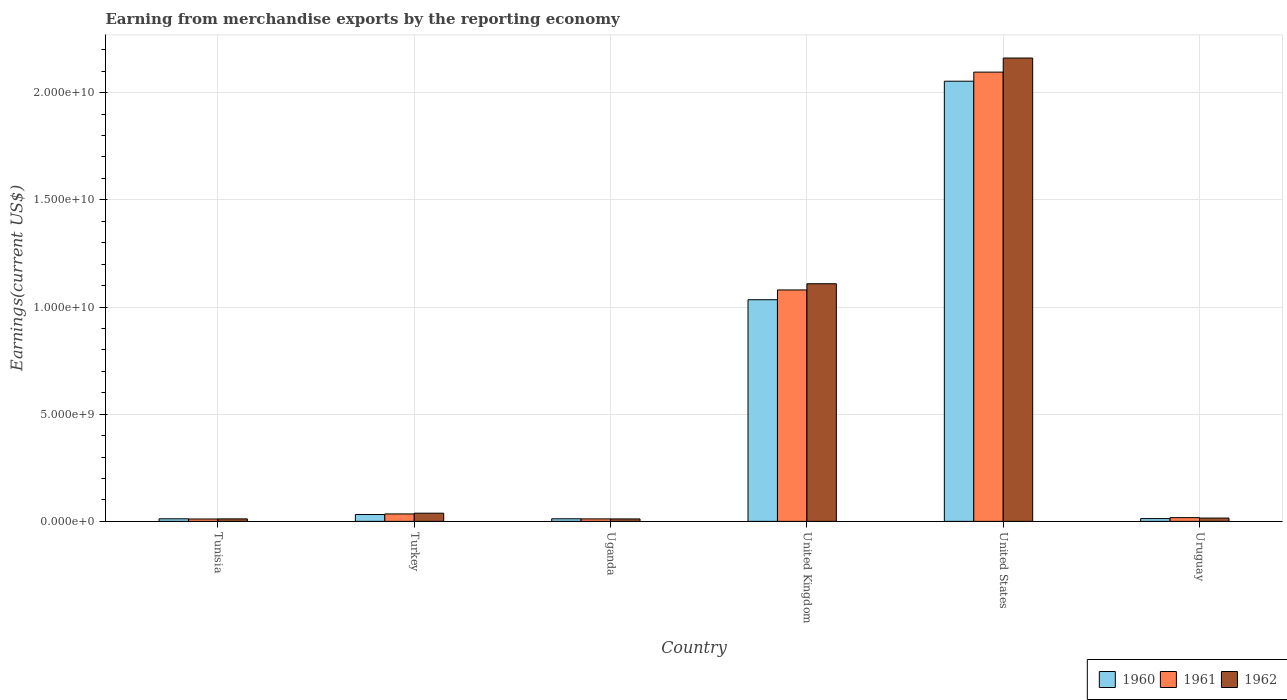How many groups of bars are there?
Keep it short and to the point. 6. Are the number of bars per tick equal to the number of legend labels?
Provide a succinct answer. Yes. Are the number of bars on each tick of the X-axis equal?
Offer a very short reply. Yes. How many bars are there on the 5th tick from the left?
Give a very brief answer. 3. How many bars are there on the 2nd tick from the right?
Offer a very short reply. 3. What is the label of the 6th group of bars from the left?
Your answer should be very brief. Uruguay. In how many cases, is the number of bars for a given country not equal to the number of legend labels?
Ensure brevity in your answer.  0. What is the amount earned from merchandise exports in 1961 in United Kingdom?
Your answer should be very brief. 1.08e+1. Across all countries, what is the maximum amount earned from merchandise exports in 1960?
Your answer should be compact. 2.05e+1. Across all countries, what is the minimum amount earned from merchandise exports in 1961?
Offer a terse response. 1.10e+08. In which country was the amount earned from merchandise exports in 1961 maximum?
Provide a succinct answer. United States. In which country was the amount earned from merchandise exports in 1962 minimum?
Offer a terse response. Uganda. What is the total amount earned from merchandise exports in 1961 in the graph?
Make the answer very short. 3.25e+1. What is the difference between the amount earned from merchandise exports in 1960 in Turkey and that in Uruguay?
Provide a succinct answer. 1.90e+08. What is the difference between the amount earned from merchandise exports in 1960 in United Kingdom and the amount earned from merchandise exports in 1962 in Tunisia?
Offer a very short reply. 1.02e+1. What is the average amount earned from merchandise exports in 1960 per country?
Your answer should be very brief. 5.26e+09. What is the difference between the amount earned from merchandise exports of/in 1960 and amount earned from merchandise exports of/in 1962 in Uruguay?
Provide a short and direct response. -2.38e+07. What is the ratio of the amount earned from merchandise exports in 1962 in United Kingdom to that in Uruguay?
Keep it short and to the point. 72.32. Is the amount earned from merchandise exports in 1962 in Tunisia less than that in United States?
Provide a short and direct response. Yes. What is the difference between the highest and the second highest amount earned from merchandise exports in 1962?
Ensure brevity in your answer.  1.05e+1. What is the difference between the highest and the lowest amount earned from merchandise exports in 1960?
Provide a short and direct response. 2.04e+1. In how many countries, is the amount earned from merchandise exports in 1962 greater than the average amount earned from merchandise exports in 1962 taken over all countries?
Provide a succinct answer. 2. What does the 2nd bar from the left in Tunisia represents?
Offer a terse response. 1961. What does the 1st bar from the right in Turkey represents?
Your answer should be compact. 1962. Is it the case that in every country, the sum of the amount earned from merchandise exports in 1960 and amount earned from merchandise exports in 1961 is greater than the amount earned from merchandise exports in 1962?
Your answer should be compact. Yes. How many bars are there?
Give a very brief answer. 18. What is the difference between two consecutive major ticks on the Y-axis?
Offer a very short reply. 5.00e+09. Are the values on the major ticks of Y-axis written in scientific E-notation?
Your response must be concise. Yes. Does the graph contain any zero values?
Keep it short and to the point. No. Where does the legend appear in the graph?
Make the answer very short. Bottom right. What is the title of the graph?
Your answer should be compact. Earning from merchandise exports by the reporting economy. What is the label or title of the Y-axis?
Your answer should be compact. Earnings(current US$). What is the Earnings(current US$) of 1960 in Tunisia?
Offer a very short reply. 1.20e+08. What is the Earnings(current US$) in 1961 in Tunisia?
Your answer should be very brief. 1.10e+08. What is the Earnings(current US$) in 1962 in Tunisia?
Ensure brevity in your answer.  1.16e+08. What is the Earnings(current US$) in 1960 in Turkey?
Keep it short and to the point. 3.19e+08. What is the Earnings(current US$) in 1961 in Turkey?
Your answer should be very brief. 3.47e+08. What is the Earnings(current US$) of 1962 in Turkey?
Your answer should be compact. 3.81e+08. What is the Earnings(current US$) of 1960 in Uganda?
Your response must be concise. 1.20e+08. What is the Earnings(current US$) in 1961 in Uganda?
Your answer should be very brief. 1.15e+08. What is the Earnings(current US$) of 1962 in Uganda?
Make the answer very short. 1.14e+08. What is the Earnings(current US$) in 1960 in United Kingdom?
Your response must be concise. 1.03e+1. What is the Earnings(current US$) of 1961 in United Kingdom?
Make the answer very short. 1.08e+1. What is the Earnings(current US$) in 1962 in United Kingdom?
Provide a short and direct response. 1.11e+1. What is the Earnings(current US$) of 1960 in United States?
Give a very brief answer. 2.05e+1. What is the Earnings(current US$) in 1961 in United States?
Your answer should be very brief. 2.10e+1. What is the Earnings(current US$) in 1962 in United States?
Ensure brevity in your answer.  2.16e+1. What is the Earnings(current US$) of 1960 in Uruguay?
Offer a terse response. 1.30e+08. What is the Earnings(current US$) of 1961 in Uruguay?
Your answer should be compact. 1.74e+08. What is the Earnings(current US$) in 1962 in Uruguay?
Offer a terse response. 1.53e+08. Across all countries, what is the maximum Earnings(current US$) in 1960?
Make the answer very short. 2.05e+1. Across all countries, what is the maximum Earnings(current US$) in 1961?
Give a very brief answer. 2.10e+1. Across all countries, what is the maximum Earnings(current US$) of 1962?
Your response must be concise. 2.16e+1. Across all countries, what is the minimum Earnings(current US$) in 1960?
Offer a very short reply. 1.20e+08. Across all countries, what is the minimum Earnings(current US$) of 1961?
Give a very brief answer. 1.10e+08. Across all countries, what is the minimum Earnings(current US$) of 1962?
Your answer should be very brief. 1.14e+08. What is the total Earnings(current US$) of 1960 in the graph?
Ensure brevity in your answer.  3.16e+1. What is the total Earnings(current US$) in 1961 in the graph?
Your answer should be very brief. 3.25e+1. What is the total Earnings(current US$) of 1962 in the graph?
Give a very brief answer. 3.35e+1. What is the difference between the Earnings(current US$) in 1960 in Tunisia and that in Turkey?
Provide a succinct answer. -2.00e+08. What is the difference between the Earnings(current US$) in 1961 in Tunisia and that in Turkey?
Keep it short and to the point. -2.37e+08. What is the difference between the Earnings(current US$) in 1962 in Tunisia and that in Turkey?
Offer a very short reply. -2.65e+08. What is the difference between the Earnings(current US$) of 1960 in Tunisia and that in Uganda?
Give a very brief answer. -6.00e+05. What is the difference between the Earnings(current US$) of 1961 in Tunisia and that in Uganda?
Offer a very short reply. -4.70e+06. What is the difference between the Earnings(current US$) of 1962 in Tunisia and that in Uganda?
Keep it short and to the point. 2.10e+06. What is the difference between the Earnings(current US$) of 1960 in Tunisia and that in United Kingdom?
Ensure brevity in your answer.  -1.02e+1. What is the difference between the Earnings(current US$) of 1961 in Tunisia and that in United Kingdom?
Make the answer very short. -1.07e+1. What is the difference between the Earnings(current US$) of 1962 in Tunisia and that in United Kingdom?
Offer a very short reply. -1.10e+1. What is the difference between the Earnings(current US$) of 1960 in Tunisia and that in United States?
Provide a short and direct response. -2.04e+1. What is the difference between the Earnings(current US$) of 1961 in Tunisia and that in United States?
Your answer should be very brief. -2.08e+1. What is the difference between the Earnings(current US$) in 1962 in Tunisia and that in United States?
Offer a very short reply. -2.15e+1. What is the difference between the Earnings(current US$) in 1960 in Tunisia and that in Uruguay?
Provide a short and direct response. -1.00e+07. What is the difference between the Earnings(current US$) of 1961 in Tunisia and that in Uruguay?
Ensure brevity in your answer.  -6.40e+07. What is the difference between the Earnings(current US$) of 1962 in Tunisia and that in Uruguay?
Offer a terse response. -3.76e+07. What is the difference between the Earnings(current US$) of 1960 in Turkey and that in Uganda?
Provide a succinct answer. 1.99e+08. What is the difference between the Earnings(current US$) of 1961 in Turkey and that in Uganda?
Provide a succinct answer. 2.32e+08. What is the difference between the Earnings(current US$) of 1962 in Turkey and that in Uganda?
Your answer should be compact. 2.67e+08. What is the difference between the Earnings(current US$) in 1960 in Turkey and that in United Kingdom?
Make the answer very short. -1.00e+1. What is the difference between the Earnings(current US$) of 1961 in Turkey and that in United Kingdom?
Provide a succinct answer. -1.05e+1. What is the difference between the Earnings(current US$) of 1962 in Turkey and that in United Kingdom?
Offer a very short reply. -1.07e+1. What is the difference between the Earnings(current US$) of 1960 in Turkey and that in United States?
Make the answer very short. -2.02e+1. What is the difference between the Earnings(current US$) in 1961 in Turkey and that in United States?
Keep it short and to the point. -2.06e+1. What is the difference between the Earnings(current US$) in 1962 in Turkey and that in United States?
Ensure brevity in your answer.  -2.12e+1. What is the difference between the Earnings(current US$) in 1960 in Turkey and that in Uruguay?
Offer a very short reply. 1.90e+08. What is the difference between the Earnings(current US$) in 1961 in Turkey and that in Uruguay?
Give a very brief answer. 1.73e+08. What is the difference between the Earnings(current US$) in 1962 in Turkey and that in Uruguay?
Ensure brevity in your answer.  2.28e+08. What is the difference between the Earnings(current US$) of 1960 in Uganda and that in United Kingdom?
Provide a short and direct response. -1.02e+1. What is the difference between the Earnings(current US$) in 1961 in Uganda and that in United Kingdom?
Your answer should be compact. -1.07e+1. What is the difference between the Earnings(current US$) in 1962 in Uganda and that in United Kingdom?
Offer a terse response. -1.10e+1. What is the difference between the Earnings(current US$) of 1960 in Uganda and that in United States?
Give a very brief answer. -2.04e+1. What is the difference between the Earnings(current US$) of 1961 in Uganda and that in United States?
Make the answer very short. -2.08e+1. What is the difference between the Earnings(current US$) in 1962 in Uganda and that in United States?
Keep it short and to the point. -2.15e+1. What is the difference between the Earnings(current US$) of 1960 in Uganda and that in Uruguay?
Keep it short and to the point. -9.40e+06. What is the difference between the Earnings(current US$) in 1961 in Uganda and that in Uruguay?
Your answer should be very brief. -5.93e+07. What is the difference between the Earnings(current US$) in 1962 in Uganda and that in Uruguay?
Your answer should be compact. -3.97e+07. What is the difference between the Earnings(current US$) of 1960 in United Kingdom and that in United States?
Keep it short and to the point. -1.02e+1. What is the difference between the Earnings(current US$) in 1961 in United Kingdom and that in United States?
Ensure brevity in your answer.  -1.02e+1. What is the difference between the Earnings(current US$) of 1962 in United Kingdom and that in United States?
Offer a terse response. -1.05e+1. What is the difference between the Earnings(current US$) in 1960 in United Kingdom and that in Uruguay?
Your answer should be compact. 1.02e+1. What is the difference between the Earnings(current US$) of 1961 in United Kingdom and that in Uruguay?
Offer a very short reply. 1.06e+1. What is the difference between the Earnings(current US$) in 1962 in United Kingdom and that in Uruguay?
Ensure brevity in your answer.  1.09e+1. What is the difference between the Earnings(current US$) of 1960 in United States and that in Uruguay?
Your answer should be compact. 2.04e+1. What is the difference between the Earnings(current US$) of 1961 in United States and that in Uruguay?
Make the answer very short. 2.08e+1. What is the difference between the Earnings(current US$) in 1962 in United States and that in Uruguay?
Give a very brief answer. 2.15e+1. What is the difference between the Earnings(current US$) in 1960 in Tunisia and the Earnings(current US$) in 1961 in Turkey?
Make the answer very short. -2.28e+08. What is the difference between the Earnings(current US$) of 1960 in Tunisia and the Earnings(current US$) of 1962 in Turkey?
Provide a succinct answer. -2.61e+08. What is the difference between the Earnings(current US$) in 1961 in Tunisia and the Earnings(current US$) in 1962 in Turkey?
Your answer should be compact. -2.71e+08. What is the difference between the Earnings(current US$) of 1960 in Tunisia and the Earnings(current US$) of 1961 in Uganda?
Your response must be concise. 4.50e+06. What is the difference between the Earnings(current US$) of 1960 in Tunisia and the Earnings(current US$) of 1962 in Uganda?
Offer a terse response. 5.90e+06. What is the difference between the Earnings(current US$) in 1961 in Tunisia and the Earnings(current US$) in 1962 in Uganda?
Keep it short and to the point. -3.30e+06. What is the difference between the Earnings(current US$) in 1960 in Tunisia and the Earnings(current US$) in 1961 in United Kingdom?
Offer a very short reply. -1.07e+1. What is the difference between the Earnings(current US$) of 1960 in Tunisia and the Earnings(current US$) of 1962 in United Kingdom?
Ensure brevity in your answer.  -1.10e+1. What is the difference between the Earnings(current US$) of 1961 in Tunisia and the Earnings(current US$) of 1962 in United Kingdom?
Give a very brief answer. -1.10e+1. What is the difference between the Earnings(current US$) in 1960 in Tunisia and the Earnings(current US$) in 1961 in United States?
Provide a succinct answer. -2.08e+1. What is the difference between the Earnings(current US$) of 1960 in Tunisia and the Earnings(current US$) of 1962 in United States?
Your answer should be very brief. -2.15e+1. What is the difference between the Earnings(current US$) of 1961 in Tunisia and the Earnings(current US$) of 1962 in United States?
Offer a terse response. -2.15e+1. What is the difference between the Earnings(current US$) in 1960 in Tunisia and the Earnings(current US$) in 1961 in Uruguay?
Your response must be concise. -5.48e+07. What is the difference between the Earnings(current US$) in 1960 in Tunisia and the Earnings(current US$) in 1962 in Uruguay?
Provide a short and direct response. -3.38e+07. What is the difference between the Earnings(current US$) of 1961 in Tunisia and the Earnings(current US$) of 1962 in Uruguay?
Keep it short and to the point. -4.30e+07. What is the difference between the Earnings(current US$) of 1960 in Turkey and the Earnings(current US$) of 1961 in Uganda?
Make the answer very short. 2.04e+08. What is the difference between the Earnings(current US$) in 1960 in Turkey and the Earnings(current US$) in 1962 in Uganda?
Your answer should be compact. 2.05e+08. What is the difference between the Earnings(current US$) of 1961 in Turkey and the Earnings(current US$) of 1962 in Uganda?
Your answer should be compact. 2.33e+08. What is the difference between the Earnings(current US$) of 1960 in Turkey and the Earnings(current US$) of 1961 in United Kingdom?
Provide a short and direct response. -1.05e+1. What is the difference between the Earnings(current US$) in 1960 in Turkey and the Earnings(current US$) in 1962 in United Kingdom?
Offer a very short reply. -1.08e+1. What is the difference between the Earnings(current US$) in 1961 in Turkey and the Earnings(current US$) in 1962 in United Kingdom?
Make the answer very short. -1.07e+1. What is the difference between the Earnings(current US$) in 1960 in Turkey and the Earnings(current US$) in 1961 in United States?
Your answer should be very brief. -2.06e+1. What is the difference between the Earnings(current US$) in 1960 in Turkey and the Earnings(current US$) in 1962 in United States?
Provide a short and direct response. -2.13e+1. What is the difference between the Earnings(current US$) in 1961 in Turkey and the Earnings(current US$) in 1962 in United States?
Provide a short and direct response. -2.13e+1. What is the difference between the Earnings(current US$) of 1960 in Turkey and the Earnings(current US$) of 1961 in Uruguay?
Keep it short and to the point. 1.45e+08. What is the difference between the Earnings(current US$) in 1960 in Turkey and the Earnings(current US$) in 1962 in Uruguay?
Provide a short and direct response. 1.66e+08. What is the difference between the Earnings(current US$) of 1961 in Turkey and the Earnings(current US$) of 1962 in Uruguay?
Your answer should be very brief. 1.94e+08. What is the difference between the Earnings(current US$) in 1960 in Uganda and the Earnings(current US$) in 1961 in United Kingdom?
Your answer should be very brief. -1.07e+1. What is the difference between the Earnings(current US$) in 1960 in Uganda and the Earnings(current US$) in 1962 in United Kingdom?
Your answer should be compact. -1.10e+1. What is the difference between the Earnings(current US$) in 1961 in Uganda and the Earnings(current US$) in 1962 in United Kingdom?
Give a very brief answer. -1.10e+1. What is the difference between the Earnings(current US$) in 1960 in Uganda and the Earnings(current US$) in 1961 in United States?
Give a very brief answer. -2.08e+1. What is the difference between the Earnings(current US$) in 1960 in Uganda and the Earnings(current US$) in 1962 in United States?
Your answer should be compact. -2.15e+1. What is the difference between the Earnings(current US$) of 1961 in Uganda and the Earnings(current US$) of 1962 in United States?
Provide a succinct answer. -2.15e+1. What is the difference between the Earnings(current US$) in 1960 in Uganda and the Earnings(current US$) in 1961 in Uruguay?
Your answer should be very brief. -5.42e+07. What is the difference between the Earnings(current US$) in 1960 in Uganda and the Earnings(current US$) in 1962 in Uruguay?
Your answer should be very brief. -3.32e+07. What is the difference between the Earnings(current US$) of 1961 in Uganda and the Earnings(current US$) of 1962 in Uruguay?
Keep it short and to the point. -3.83e+07. What is the difference between the Earnings(current US$) of 1960 in United Kingdom and the Earnings(current US$) of 1961 in United States?
Provide a succinct answer. -1.06e+1. What is the difference between the Earnings(current US$) of 1960 in United Kingdom and the Earnings(current US$) of 1962 in United States?
Offer a terse response. -1.13e+1. What is the difference between the Earnings(current US$) of 1961 in United Kingdom and the Earnings(current US$) of 1962 in United States?
Give a very brief answer. -1.08e+1. What is the difference between the Earnings(current US$) of 1960 in United Kingdom and the Earnings(current US$) of 1961 in Uruguay?
Keep it short and to the point. 1.02e+1. What is the difference between the Earnings(current US$) of 1960 in United Kingdom and the Earnings(current US$) of 1962 in Uruguay?
Provide a short and direct response. 1.02e+1. What is the difference between the Earnings(current US$) of 1961 in United Kingdom and the Earnings(current US$) of 1962 in Uruguay?
Ensure brevity in your answer.  1.06e+1. What is the difference between the Earnings(current US$) in 1960 in United States and the Earnings(current US$) in 1961 in Uruguay?
Your answer should be very brief. 2.04e+1. What is the difference between the Earnings(current US$) of 1960 in United States and the Earnings(current US$) of 1962 in Uruguay?
Make the answer very short. 2.04e+1. What is the difference between the Earnings(current US$) in 1961 in United States and the Earnings(current US$) in 1962 in Uruguay?
Your response must be concise. 2.08e+1. What is the average Earnings(current US$) of 1960 per country?
Offer a terse response. 5.26e+09. What is the average Earnings(current US$) of 1961 per country?
Provide a succinct answer. 5.42e+09. What is the average Earnings(current US$) in 1962 per country?
Offer a terse response. 5.58e+09. What is the difference between the Earnings(current US$) of 1960 and Earnings(current US$) of 1961 in Tunisia?
Your response must be concise. 9.20e+06. What is the difference between the Earnings(current US$) of 1960 and Earnings(current US$) of 1962 in Tunisia?
Ensure brevity in your answer.  3.80e+06. What is the difference between the Earnings(current US$) in 1961 and Earnings(current US$) in 1962 in Tunisia?
Offer a very short reply. -5.40e+06. What is the difference between the Earnings(current US$) in 1960 and Earnings(current US$) in 1961 in Turkey?
Make the answer very short. -2.80e+07. What is the difference between the Earnings(current US$) of 1960 and Earnings(current US$) of 1962 in Turkey?
Provide a short and direct response. -6.19e+07. What is the difference between the Earnings(current US$) in 1961 and Earnings(current US$) in 1962 in Turkey?
Your answer should be very brief. -3.39e+07. What is the difference between the Earnings(current US$) in 1960 and Earnings(current US$) in 1961 in Uganda?
Your answer should be very brief. 5.10e+06. What is the difference between the Earnings(current US$) in 1960 and Earnings(current US$) in 1962 in Uganda?
Your answer should be compact. 6.50e+06. What is the difference between the Earnings(current US$) of 1961 and Earnings(current US$) of 1962 in Uganda?
Your answer should be very brief. 1.40e+06. What is the difference between the Earnings(current US$) of 1960 and Earnings(current US$) of 1961 in United Kingdom?
Ensure brevity in your answer.  -4.56e+08. What is the difference between the Earnings(current US$) in 1960 and Earnings(current US$) in 1962 in United Kingdom?
Your answer should be compact. -7.45e+08. What is the difference between the Earnings(current US$) in 1961 and Earnings(current US$) in 1962 in United Kingdom?
Your answer should be compact. -2.89e+08. What is the difference between the Earnings(current US$) in 1960 and Earnings(current US$) in 1961 in United States?
Your answer should be compact. -4.24e+08. What is the difference between the Earnings(current US$) of 1960 and Earnings(current US$) of 1962 in United States?
Offer a terse response. -1.08e+09. What is the difference between the Earnings(current US$) of 1961 and Earnings(current US$) of 1962 in United States?
Ensure brevity in your answer.  -6.57e+08. What is the difference between the Earnings(current US$) of 1960 and Earnings(current US$) of 1961 in Uruguay?
Your answer should be compact. -4.48e+07. What is the difference between the Earnings(current US$) of 1960 and Earnings(current US$) of 1962 in Uruguay?
Provide a succinct answer. -2.38e+07. What is the difference between the Earnings(current US$) of 1961 and Earnings(current US$) of 1962 in Uruguay?
Provide a short and direct response. 2.10e+07. What is the ratio of the Earnings(current US$) in 1960 in Tunisia to that in Turkey?
Give a very brief answer. 0.37. What is the ratio of the Earnings(current US$) of 1961 in Tunisia to that in Turkey?
Offer a terse response. 0.32. What is the ratio of the Earnings(current US$) in 1962 in Tunisia to that in Turkey?
Give a very brief answer. 0.3. What is the ratio of the Earnings(current US$) of 1960 in Tunisia to that in Uganda?
Ensure brevity in your answer.  0.99. What is the ratio of the Earnings(current US$) of 1961 in Tunisia to that in Uganda?
Provide a succinct answer. 0.96. What is the ratio of the Earnings(current US$) of 1962 in Tunisia to that in Uganda?
Provide a short and direct response. 1.02. What is the ratio of the Earnings(current US$) in 1960 in Tunisia to that in United Kingdom?
Ensure brevity in your answer.  0.01. What is the ratio of the Earnings(current US$) of 1961 in Tunisia to that in United Kingdom?
Provide a succinct answer. 0.01. What is the ratio of the Earnings(current US$) of 1962 in Tunisia to that in United Kingdom?
Your answer should be compact. 0.01. What is the ratio of the Earnings(current US$) of 1960 in Tunisia to that in United States?
Your answer should be compact. 0.01. What is the ratio of the Earnings(current US$) in 1961 in Tunisia to that in United States?
Your answer should be very brief. 0.01. What is the ratio of the Earnings(current US$) in 1962 in Tunisia to that in United States?
Offer a very short reply. 0.01. What is the ratio of the Earnings(current US$) in 1960 in Tunisia to that in Uruguay?
Offer a terse response. 0.92. What is the ratio of the Earnings(current US$) in 1961 in Tunisia to that in Uruguay?
Your response must be concise. 0.63. What is the ratio of the Earnings(current US$) of 1962 in Tunisia to that in Uruguay?
Give a very brief answer. 0.75. What is the ratio of the Earnings(current US$) in 1960 in Turkey to that in Uganda?
Make the answer very short. 2.66. What is the ratio of the Earnings(current US$) in 1961 in Turkey to that in Uganda?
Give a very brief answer. 3.02. What is the ratio of the Earnings(current US$) of 1962 in Turkey to that in Uganda?
Provide a succinct answer. 3.35. What is the ratio of the Earnings(current US$) of 1960 in Turkey to that in United Kingdom?
Your answer should be compact. 0.03. What is the ratio of the Earnings(current US$) in 1961 in Turkey to that in United Kingdom?
Your answer should be very brief. 0.03. What is the ratio of the Earnings(current US$) of 1962 in Turkey to that in United Kingdom?
Give a very brief answer. 0.03. What is the ratio of the Earnings(current US$) of 1960 in Turkey to that in United States?
Offer a very short reply. 0.02. What is the ratio of the Earnings(current US$) in 1961 in Turkey to that in United States?
Your answer should be very brief. 0.02. What is the ratio of the Earnings(current US$) in 1962 in Turkey to that in United States?
Provide a short and direct response. 0.02. What is the ratio of the Earnings(current US$) in 1960 in Turkey to that in Uruguay?
Your answer should be very brief. 2.46. What is the ratio of the Earnings(current US$) in 1961 in Turkey to that in Uruguay?
Offer a terse response. 1.99. What is the ratio of the Earnings(current US$) in 1962 in Turkey to that in Uruguay?
Give a very brief answer. 2.48. What is the ratio of the Earnings(current US$) of 1960 in Uganda to that in United Kingdom?
Ensure brevity in your answer.  0.01. What is the ratio of the Earnings(current US$) in 1961 in Uganda to that in United Kingdom?
Offer a terse response. 0.01. What is the ratio of the Earnings(current US$) in 1962 in Uganda to that in United Kingdom?
Keep it short and to the point. 0.01. What is the ratio of the Earnings(current US$) in 1960 in Uganda to that in United States?
Provide a succinct answer. 0.01. What is the ratio of the Earnings(current US$) in 1961 in Uganda to that in United States?
Your answer should be compact. 0.01. What is the ratio of the Earnings(current US$) in 1962 in Uganda to that in United States?
Your answer should be very brief. 0.01. What is the ratio of the Earnings(current US$) in 1960 in Uganda to that in Uruguay?
Provide a succinct answer. 0.93. What is the ratio of the Earnings(current US$) in 1961 in Uganda to that in Uruguay?
Give a very brief answer. 0.66. What is the ratio of the Earnings(current US$) in 1962 in Uganda to that in Uruguay?
Make the answer very short. 0.74. What is the ratio of the Earnings(current US$) in 1960 in United Kingdom to that in United States?
Offer a terse response. 0.5. What is the ratio of the Earnings(current US$) of 1961 in United Kingdom to that in United States?
Your answer should be very brief. 0.52. What is the ratio of the Earnings(current US$) of 1962 in United Kingdom to that in United States?
Your response must be concise. 0.51. What is the ratio of the Earnings(current US$) in 1960 in United Kingdom to that in Uruguay?
Your response must be concise. 79.85. What is the ratio of the Earnings(current US$) of 1961 in United Kingdom to that in Uruguay?
Your answer should be very brief. 61.95. What is the ratio of the Earnings(current US$) in 1962 in United Kingdom to that in Uruguay?
Provide a succinct answer. 72.32. What is the ratio of the Earnings(current US$) in 1960 in United States to that in Uruguay?
Offer a terse response. 158.58. What is the ratio of the Earnings(current US$) in 1961 in United States to that in Uruguay?
Offer a very short reply. 120.25. What is the ratio of the Earnings(current US$) of 1962 in United States to that in Uruguay?
Offer a terse response. 141.01. What is the difference between the highest and the second highest Earnings(current US$) in 1960?
Your answer should be compact. 1.02e+1. What is the difference between the highest and the second highest Earnings(current US$) of 1961?
Provide a short and direct response. 1.02e+1. What is the difference between the highest and the second highest Earnings(current US$) of 1962?
Provide a short and direct response. 1.05e+1. What is the difference between the highest and the lowest Earnings(current US$) in 1960?
Provide a succinct answer. 2.04e+1. What is the difference between the highest and the lowest Earnings(current US$) of 1961?
Your answer should be compact. 2.08e+1. What is the difference between the highest and the lowest Earnings(current US$) of 1962?
Make the answer very short. 2.15e+1. 